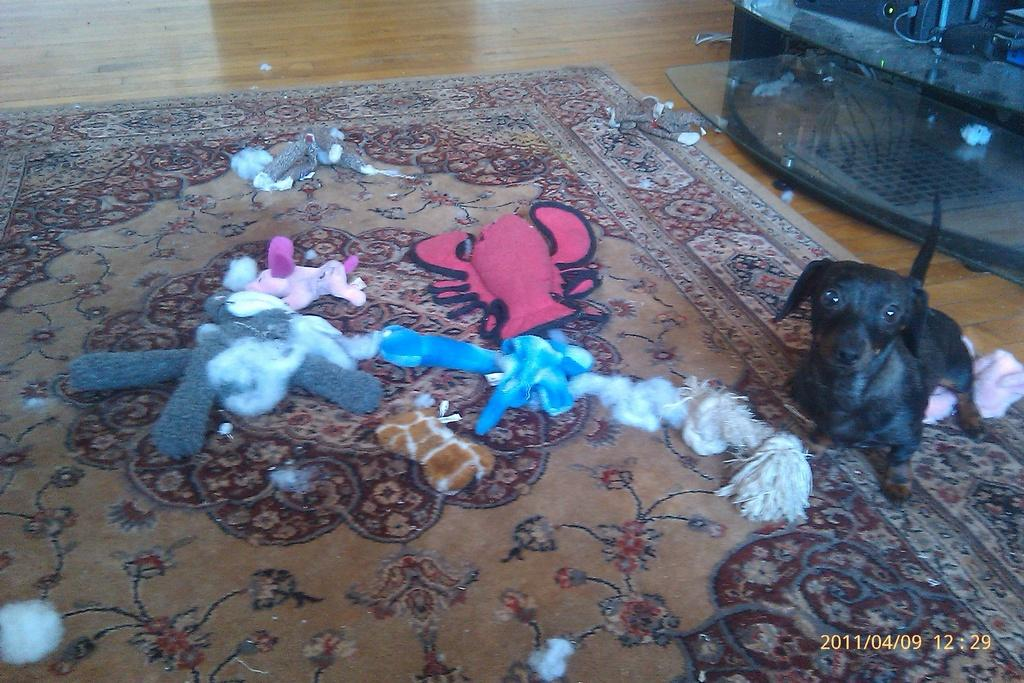What is on the mat in the image? There are toys on the mat. What type of animal is present in the image? There is a dog in the image. What type of flooring is visible in the image? There is a wooden floor visible in the image. What electronic device can be seen on a table in the image? There is an electronic gadget on a table in the image. What type of fork is being used by the dog in the image? There is no fork present in the image, and the dog is not using any utensils. What thing is being held by the dog in the image? The dog is not holding any specific thing in the image; it is simply present. 